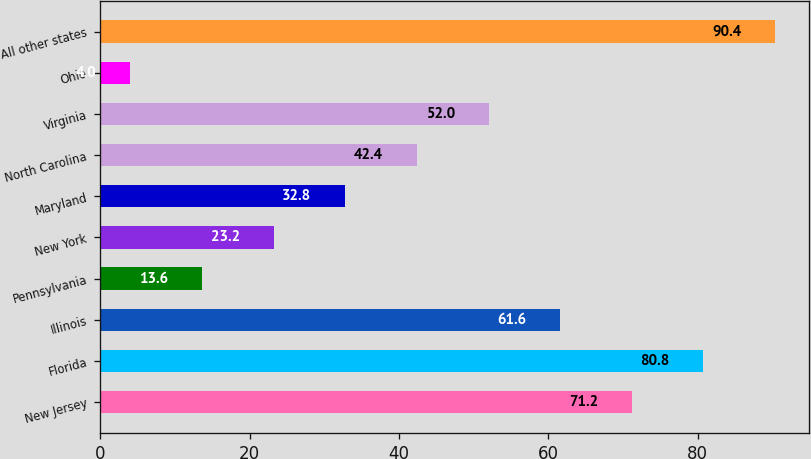Convert chart to OTSL. <chart><loc_0><loc_0><loc_500><loc_500><bar_chart><fcel>New Jersey<fcel>Florida<fcel>Illinois<fcel>Pennsylvania<fcel>New York<fcel>Maryland<fcel>North Carolina<fcel>Virginia<fcel>Ohio<fcel>All other states<nl><fcel>71.2<fcel>80.8<fcel>61.6<fcel>13.6<fcel>23.2<fcel>32.8<fcel>42.4<fcel>52<fcel>4<fcel>90.4<nl></chart> 